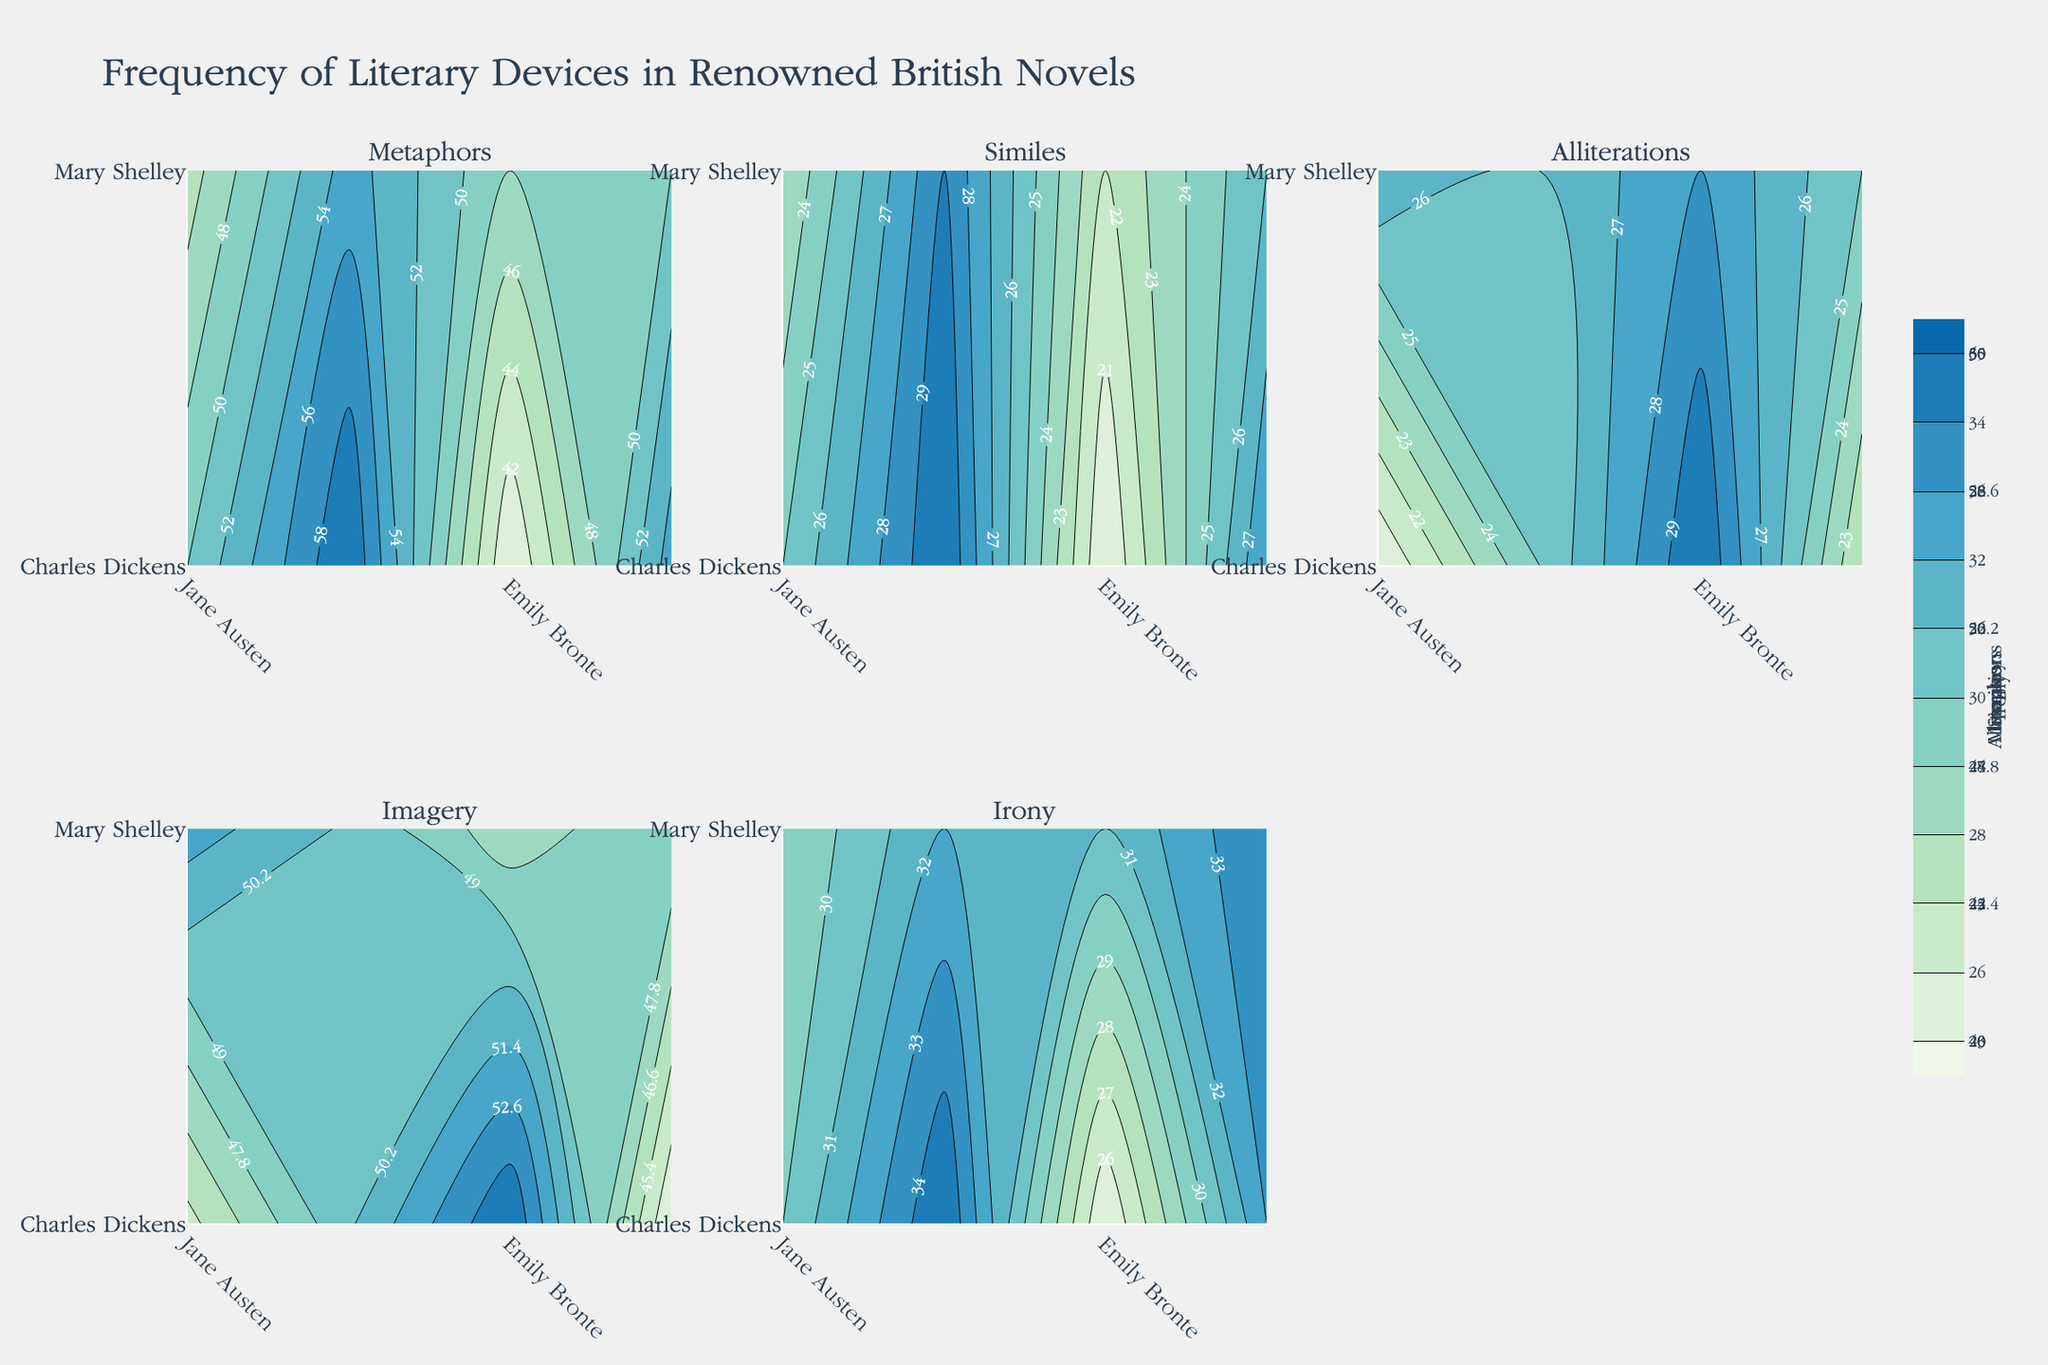Which literary device has the highest frequency in "Great Expectations" by Charles Dickens? Look at the subplot for each literary device and identify where "Great Expectations" appears. Note the frequency values. The highest frequency is in the subplot for Metaphors with a value of 60.
Answer: Metaphors In which novels is the frequency of Imagery greater than 50? Look at the Imagery subplot and identify the novels corresponding to frequency values greater than 50. The novels are "Wuthering Heights" (55), "Jane Eyre" (52).
Answer: "Wuthering Heights" and "Jane Eyre" What is the total frequency of Metaphors in "Pride and Prejudice" and "Brave New World"? Find the frequencies of Metaphors in the subplot for both novels. Sum these values: 50 for "Pride and Prejudice" and 48 for "Brave New World". The total is 50 + 48 = 98.
Answer: 98 Which novel employs more Irony, "1984" or "Frankenstein"? Check the subplot for Irony and compare the values for "1984" and "Frankenstein." "1984" has a value of 34, and "Frankenstein" has a value of 33. "1984" employs more Irony.
Answer: "1984" What is the average frequency of Alliterations in "Wuthering Heights" and "Jane Eyre"? Identify the frequency values for Alliterations in the Alliterations subplot. "Wuthering Heights" has 30, and "Jane Eyre" has 27. The average is (30 + 27) / 2 = 28.5.
Answer: 28.5 Which literary device shows the least frequency in "Jane Eyre"? Examine each subplot for "Jane Eyre" and compare the frequencies. The lowest frequency is Alliterations with a value of 27.
Answer: Alliterations Are there any novels where the frequency of Similes is over 25? Check the Similes subplot and find values exceeding 25. "Great Expectations" (30), "Frankenstein" (28), "The Picture of Dorian Gray" (29), and "1984" (26) exceed 25.
Answer: "Great Expectations", "Frankenstein", "The Picture of Dorian Gray", "1984" How does the frequency of Alliterations in "The Picture of Dorian Gray" compare to that in "Pride and Prejudice"? Check the subplot for Alliterations and compare the frequencies: "The Picture of Dorian Gray" has 26, and "Pride and Prejudice" has 20. "The Picture of Dorian Gray" has 6 more Alliterations.
Answer: 6 more in "The Picture of Dorian Gray" 